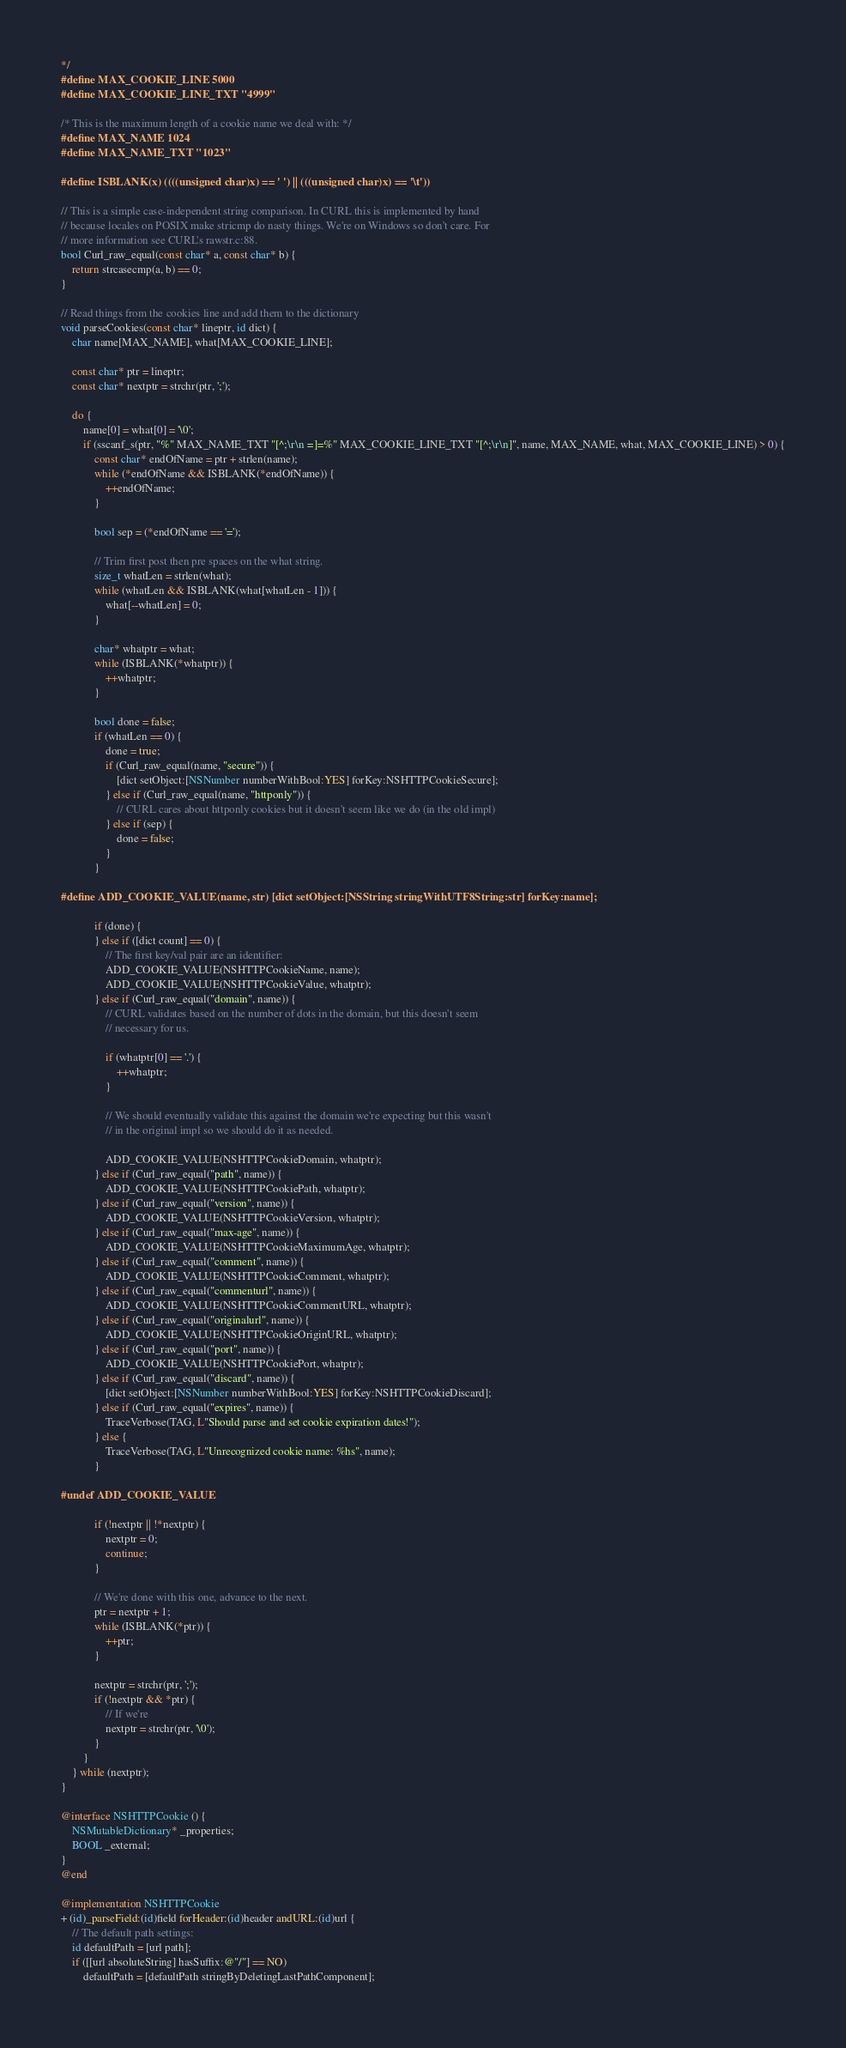Convert code to text. <code><loc_0><loc_0><loc_500><loc_500><_ObjectiveC_>
*/
#define MAX_COOKIE_LINE 5000
#define MAX_COOKIE_LINE_TXT "4999"

/* This is the maximum length of a cookie name we deal with: */
#define MAX_NAME 1024
#define MAX_NAME_TXT "1023"

#define ISBLANK(x) ((((unsigned char)x) == ' ') || (((unsigned char)x) == '\t'))

// This is a simple case-independent string comparison. In CURL this is implemented by hand
// because locales on POSIX make stricmp do nasty things. We're on Windows so don't care. For
// more information see CURL's rawstr.c:88.
bool Curl_raw_equal(const char* a, const char* b) {
    return strcasecmp(a, b) == 0;
}

// Read things from the cookies line and add them to the dictionary
void parseCookies(const char* lineptr, id dict) {
    char name[MAX_NAME], what[MAX_COOKIE_LINE];

    const char* ptr = lineptr;
    const char* nextptr = strchr(ptr, ';');

    do {
        name[0] = what[0] = '\0';
        if (sscanf_s(ptr, "%" MAX_NAME_TXT "[^;\r\n =]=%" MAX_COOKIE_LINE_TXT "[^;\r\n]", name, MAX_NAME, what, MAX_COOKIE_LINE) > 0) {
            const char* endOfName = ptr + strlen(name);
            while (*endOfName && ISBLANK(*endOfName)) {
                ++endOfName;
            }

            bool sep = (*endOfName == '=');

            // Trim first post then pre spaces on the what string.
            size_t whatLen = strlen(what);
            while (whatLen && ISBLANK(what[whatLen - 1])) {
                what[--whatLen] = 0;
            }

            char* whatptr = what;
            while (ISBLANK(*whatptr)) {
                ++whatptr;
            }

            bool done = false;
            if (whatLen == 0) {
                done = true;
                if (Curl_raw_equal(name, "secure")) {
                    [dict setObject:[NSNumber numberWithBool:YES] forKey:NSHTTPCookieSecure];
                } else if (Curl_raw_equal(name, "httponly")) {
                    // CURL cares about httponly cookies but it doesn't seem like we do (in the old impl)
                } else if (sep) {
                    done = false;
                }
            }

#define ADD_COOKIE_VALUE(name, str) [dict setObject:[NSString stringWithUTF8String:str] forKey:name];

            if (done) {
            } else if ([dict count] == 0) {
                // The first key/val pair are an identifier:
                ADD_COOKIE_VALUE(NSHTTPCookieName, name);
                ADD_COOKIE_VALUE(NSHTTPCookieValue, whatptr);
            } else if (Curl_raw_equal("domain", name)) {
                // CURL validates based on the number of dots in the domain, but this doesn't seem
                // necessary for us.

                if (whatptr[0] == '.') {
                    ++whatptr;
                }

                // We should eventually validate this against the domain we're expecting but this wasn't
                // in the original impl so we should do it as needed.

                ADD_COOKIE_VALUE(NSHTTPCookieDomain, whatptr);
            } else if (Curl_raw_equal("path", name)) {
                ADD_COOKIE_VALUE(NSHTTPCookiePath, whatptr);
            } else if (Curl_raw_equal("version", name)) {
                ADD_COOKIE_VALUE(NSHTTPCookieVersion, whatptr);
            } else if (Curl_raw_equal("max-age", name)) {
                ADD_COOKIE_VALUE(NSHTTPCookieMaximumAge, whatptr);
            } else if (Curl_raw_equal("comment", name)) {
                ADD_COOKIE_VALUE(NSHTTPCookieComment, whatptr);
            } else if (Curl_raw_equal("commenturl", name)) {
                ADD_COOKIE_VALUE(NSHTTPCookieCommentURL, whatptr);
            } else if (Curl_raw_equal("originalurl", name)) {
                ADD_COOKIE_VALUE(NSHTTPCookieOriginURL, whatptr);
            } else if (Curl_raw_equal("port", name)) {
                ADD_COOKIE_VALUE(NSHTTPCookiePort, whatptr);
            } else if (Curl_raw_equal("discard", name)) {
                [dict setObject:[NSNumber numberWithBool:YES] forKey:NSHTTPCookieDiscard];
            } else if (Curl_raw_equal("expires", name)) {
                TraceVerbose(TAG, L"Should parse and set cookie expiration dates!");
            } else {
                TraceVerbose(TAG, L"Unrecognized cookie name: %hs", name);
            }

#undef ADD_COOKIE_VALUE

            if (!nextptr || !*nextptr) {
                nextptr = 0;
                continue;
            }

            // We're done with this one, advance to the next.
            ptr = nextptr + 1;
            while (ISBLANK(*ptr)) {
                ++ptr;
            }

            nextptr = strchr(ptr, ';');
            if (!nextptr && *ptr) {
                // If we're
                nextptr = strchr(ptr, '\0');
            }
        }
    } while (nextptr);
}

@interface NSHTTPCookie () {
    NSMutableDictionary* _properties;
    BOOL _external;
}
@end

@implementation NSHTTPCookie
+ (id)_parseField:(id)field forHeader:(id)header andURL:(id)url {
    // The default path settings:
    id defaultPath = [url path];
    if ([[url absoluteString] hasSuffix:@"/"] == NO)
        defaultPath = [defaultPath stringByDeletingLastPathComponent];</code> 